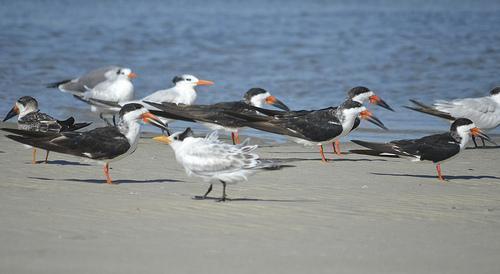How many birds are in the picture?
Give a very brief answer. 11. How many birds are there?
Give a very brief answer. 11. How many feet do the birds have?
Give a very brief answer. 2. How many wings do the birds have?
Give a very brief answer. 2. 